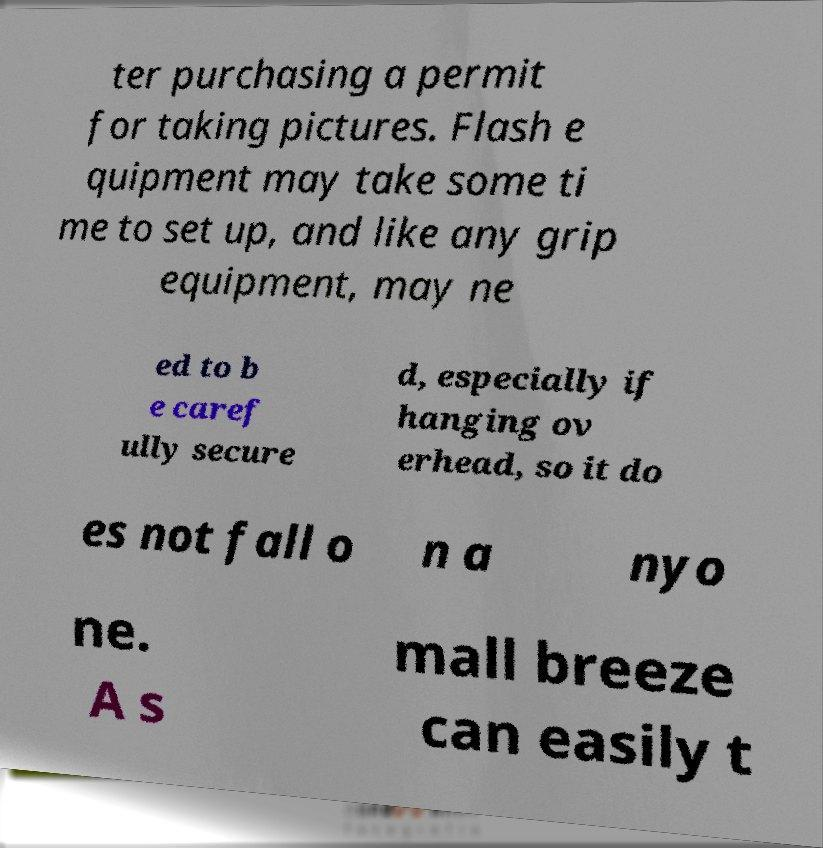Can you read and provide the text displayed in the image?This photo seems to have some interesting text. Can you extract and type it out for me? ter purchasing a permit for taking pictures. Flash e quipment may take some ti me to set up, and like any grip equipment, may ne ed to b e caref ully secure d, especially if hanging ov erhead, so it do es not fall o n a nyo ne. A s mall breeze can easily t 